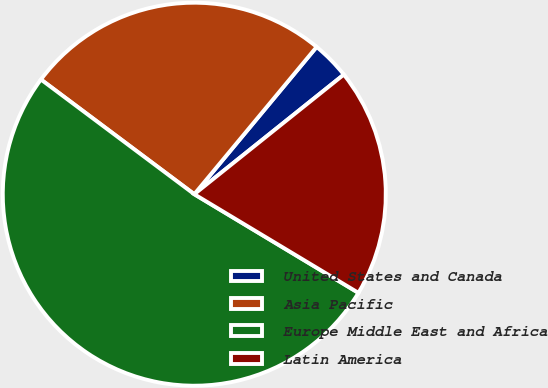Convert chart. <chart><loc_0><loc_0><loc_500><loc_500><pie_chart><fcel>United States and Canada<fcel>Asia Pacific<fcel>Europe Middle East and Africa<fcel>Latin America<nl><fcel>3.23%<fcel>25.81%<fcel>51.61%<fcel>19.35%<nl></chart> 